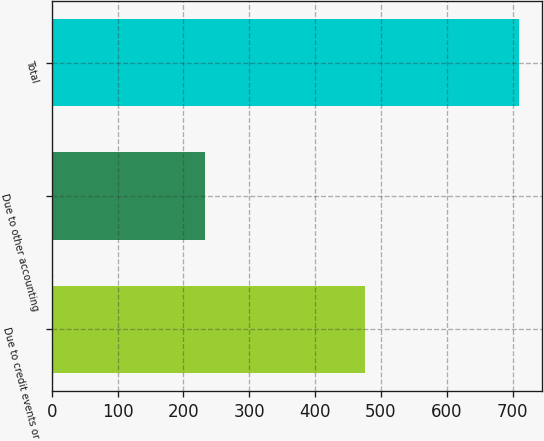<chart> <loc_0><loc_0><loc_500><loc_500><bar_chart><fcel>Due to credit events or<fcel>Due to other accounting<fcel>Total<nl><fcel>476<fcel>233<fcel>709<nl></chart> 